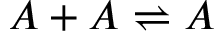<formula> <loc_0><loc_0><loc_500><loc_500>A + A \rightleftharpoons A</formula> 